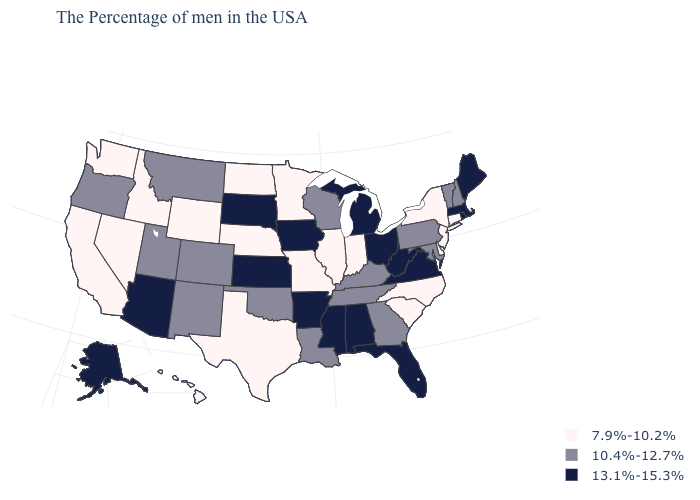Does the map have missing data?
Keep it brief. No. Does Vermont have the same value as North Carolina?
Answer briefly. No. Among the states that border New Jersey , does Pennsylvania have the highest value?
Be succinct. Yes. What is the lowest value in the West?
Answer briefly. 7.9%-10.2%. Does the first symbol in the legend represent the smallest category?
Concise answer only. Yes. What is the value of Alaska?
Quick response, please. 13.1%-15.3%. Does Indiana have the lowest value in the MidWest?
Short answer required. Yes. Among the states that border Nevada , which have the highest value?
Be succinct. Arizona. Name the states that have a value in the range 7.9%-10.2%?
Give a very brief answer. Connecticut, New York, New Jersey, Delaware, North Carolina, South Carolina, Indiana, Illinois, Missouri, Minnesota, Nebraska, Texas, North Dakota, Wyoming, Idaho, Nevada, California, Washington, Hawaii. Does the map have missing data?
Be succinct. No. Does Texas have a lower value than New Jersey?
Keep it brief. No. Among the states that border Rhode Island , which have the lowest value?
Be succinct. Connecticut. What is the highest value in the USA?
Short answer required. 13.1%-15.3%. Does Georgia have the lowest value in the USA?
Answer briefly. No. Does Illinois have a lower value than Ohio?
Quick response, please. Yes. 